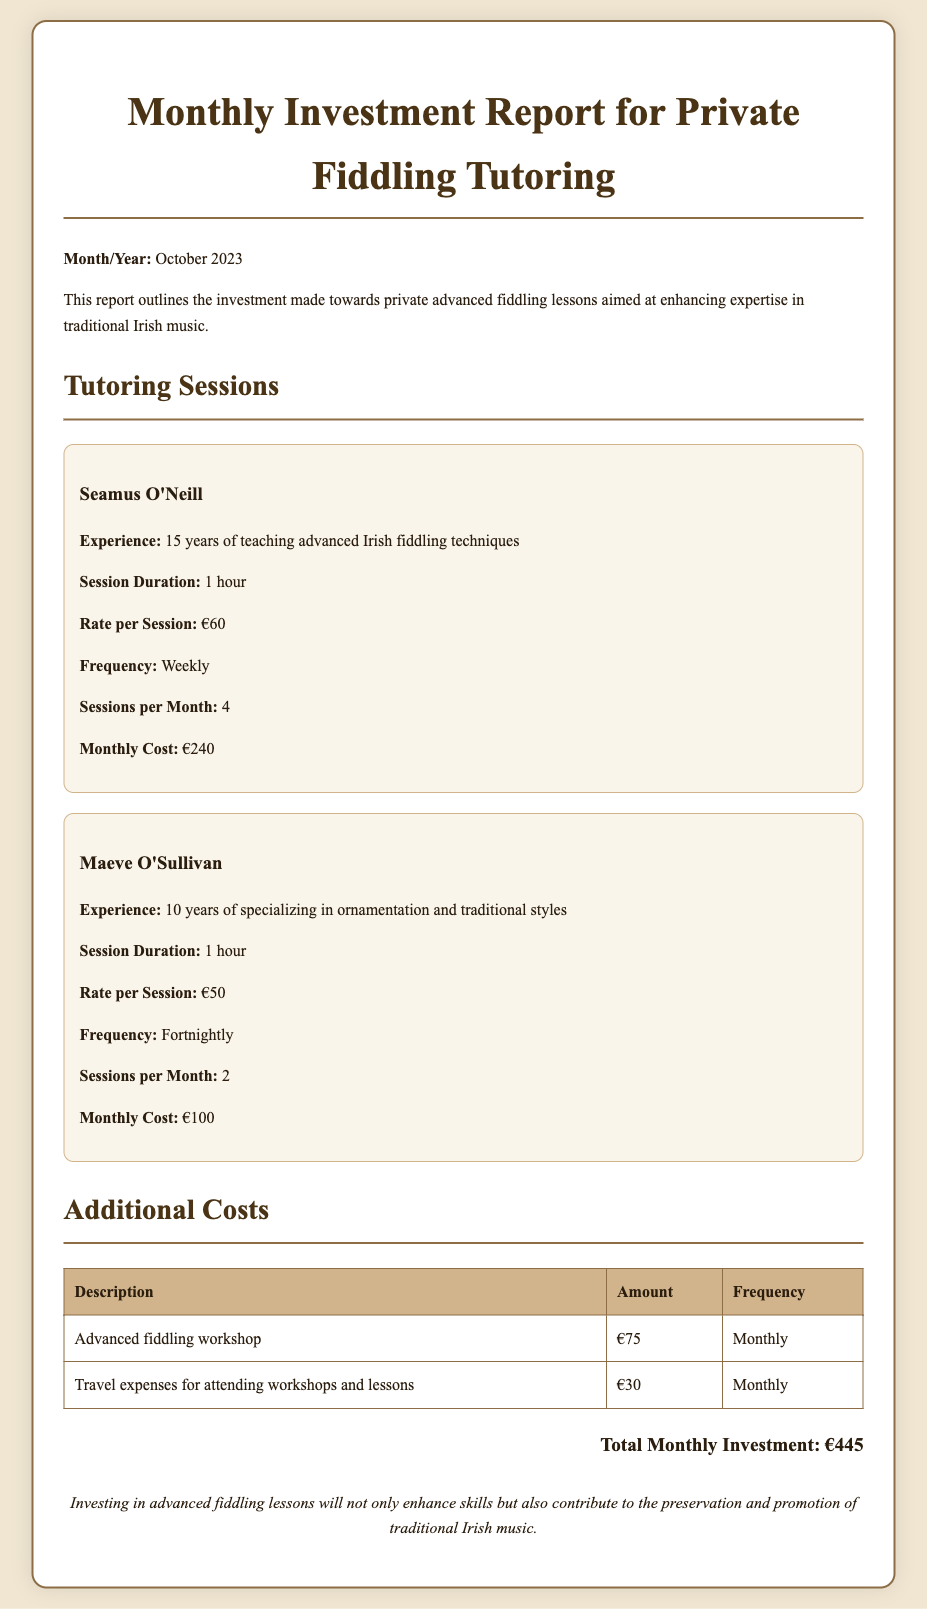What is the total monthly investment? The total monthly investment is the sum of all music lesson costs and additional expenses listed in the document, which totals €240 + €100 + €75 + €30.
Answer: €445 Who is the first tutor mentioned in the document? The first tutor mentioned is Seamus O'Neill, whose details are provided in the document.
Answer: Seamus O'Neill How many sessions does Maeve O'Sullivan conduct per month? Maeve O'Sullivan has a frequency of fortnightly sessions, which accounts for 2 sessions per month.
Answer: 2 What is the rate per session for Seamus O'Neill? The document states that the rate per session for Seamus O'Neill is €60.
Answer: €60 What additional cost is associated with travel expenses? The document lists the travel expenses as being €30 monthly, which is an additional cost of attending workshops and lessons.
Answer: €30 What is the experience of Maeve O'Sullivan? The document describes Maeve O'Sullivan as having 10 years of specializing in ornamentation and traditional styles.
Answer: 10 years How often does Seamus O'Neill conduct sessions? The document specifies that Seamus O'Neill conducts his sessions weekly, which is a frequent schedule for his tutoring.
Answer: Weekly What is the cost of the advanced fiddling workshop? The additional cost for the advanced fiddling workshop, listed in the document, is €75.
Answer: €75 How long is each tutoring session? Each tutoring session as detailed in the document lasts for 1 hour.
Answer: 1 hour 